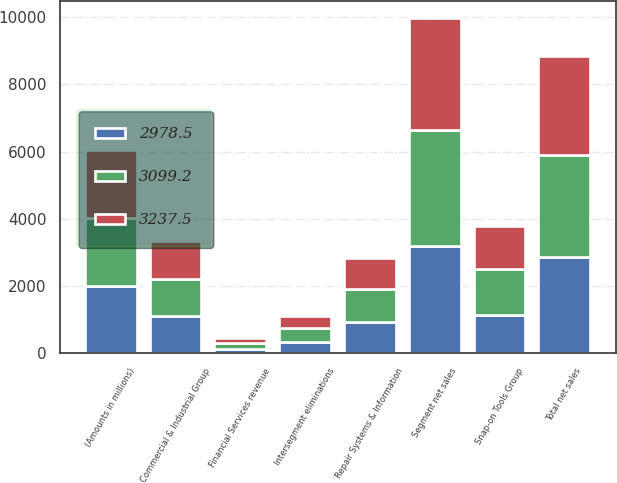Convert chart to OTSL. <chart><loc_0><loc_0><loc_500><loc_500><stacked_bar_chart><ecel><fcel>(Amounts in millions)<fcel>Commercial & Industrial Group<fcel>Snap-on Tools Group<fcel>Repair Systems & Information<fcel>Segment net sales<fcel>Intersegment eliminations<fcel>Total net sales<fcel>Financial Services revenue<nl><fcel>3099.2<fcel>2013<fcel>1091<fcel>1358.4<fcel>1009.6<fcel>3459<fcel>402.5<fcel>3056.5<fcel>181<nl><fcel>3237.5<fcel>2012<fcel>1125.9<fcel>1272<fcel>917.1<fcel>3315<fcel>377.1<fcel>2937.9<fcel>161.3<nl><fcel>2978.5<fcel>2011<fcel>1125.8<fcel>1153.4<fcel>920.6<fcel>3199.8<fcel>345.6<fcel>2854.2<fcel>124.3<nl></chart> 